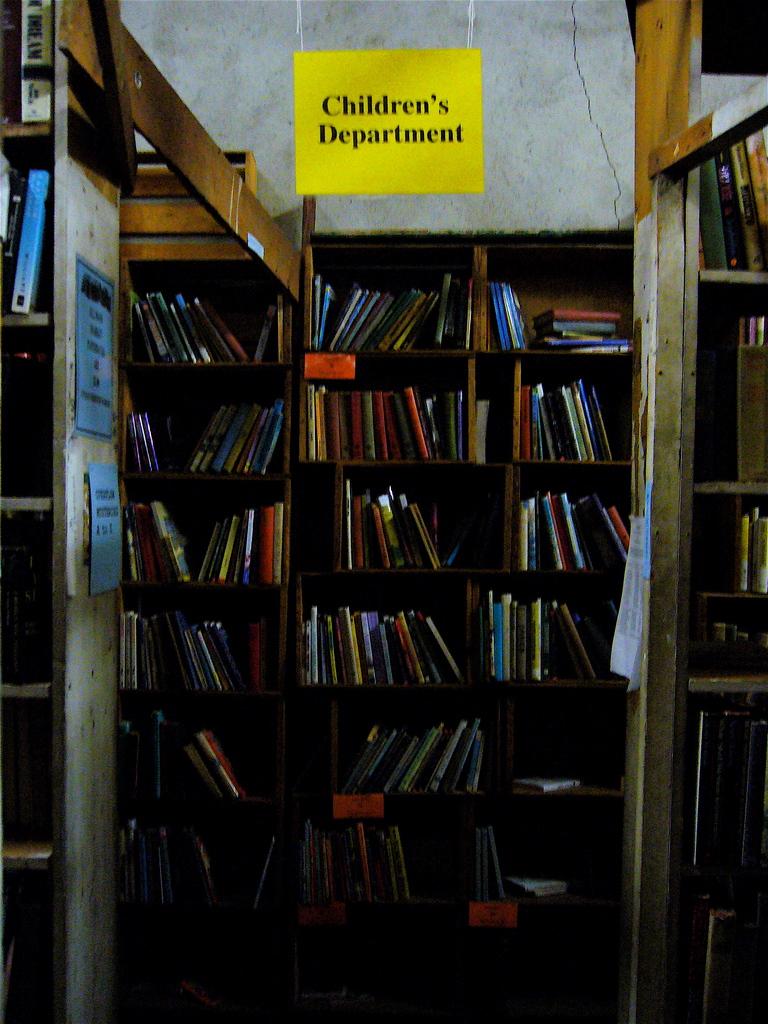Is that a library?
Your answer should be very brief. Yes. 